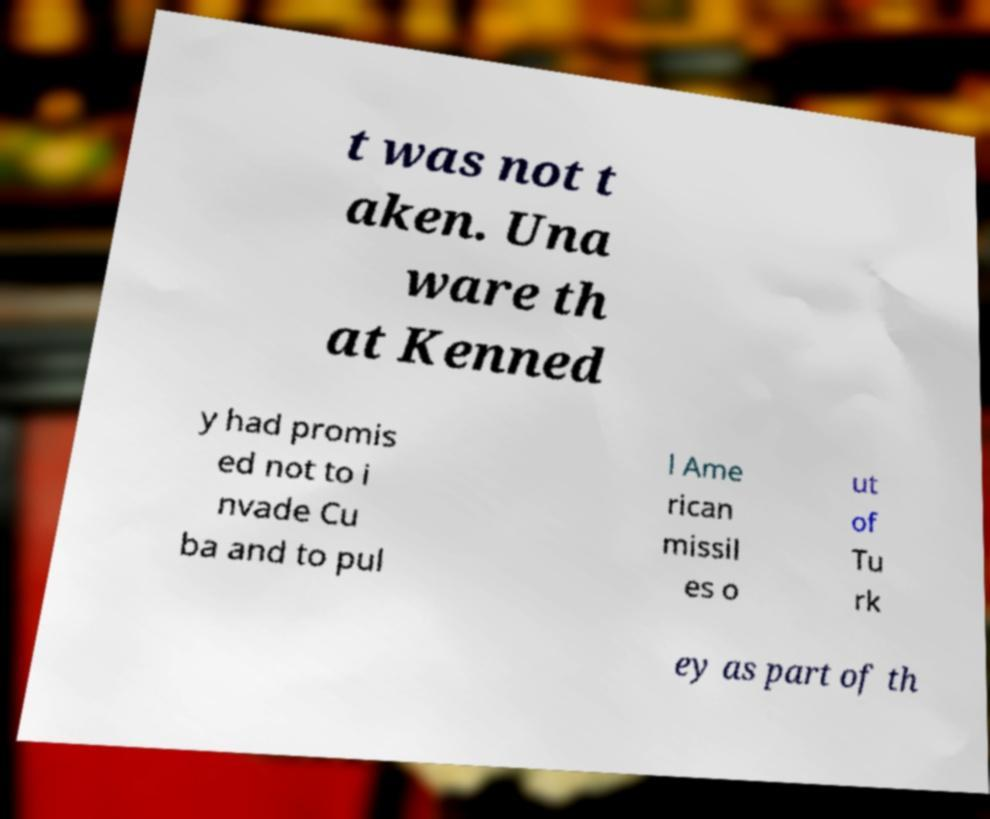There's text embedded in this image that I need extracted. Can you transcribe it verbatim? t was not t aken. Una ware th at Kenned y had promis ed not to i nvade Cu ba and to pul l Ame rican missil es o ut of Tu rk ey as part of th 